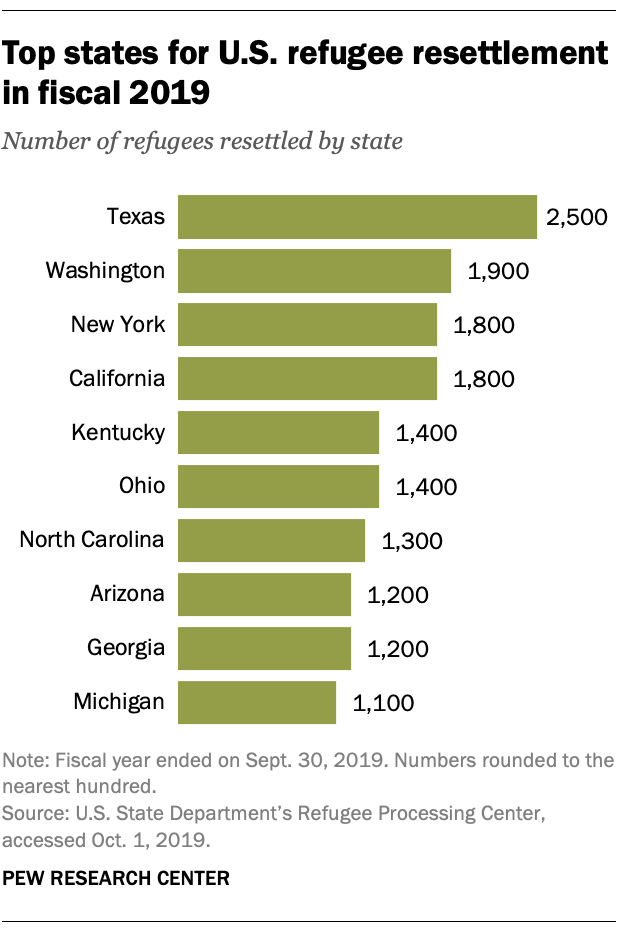Mention a couple of crucial points in this snapshot. There are approximately 3500 refugees in the states of Michigan, Georgia, and Arizona. There are currently 1800 refugees residing in New York. 